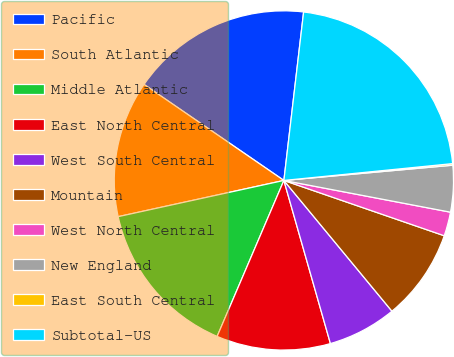Convert chart to OTSL. <chart><loc_0><loc_0><loc_500><loc_500><pie_chart><fcel>Pacific<fcel>South Atlantic<fcel>Middle Atlantic<fcel>East North Central<fcel>West South Central<fcel>Mountain<fcel>West North Central<fcel>New England<fcel>East South Central<fcel>Subtotal-US<nl><fcel>17.28%<fcel>13.0%<fcel>15.14%<fcel>10.86%<fcel>6.57%<fcel>8.72%<fcel>2.29%<fcel>4.43%<fcel>0.15%<fcel>21.56%<nl></chart> 